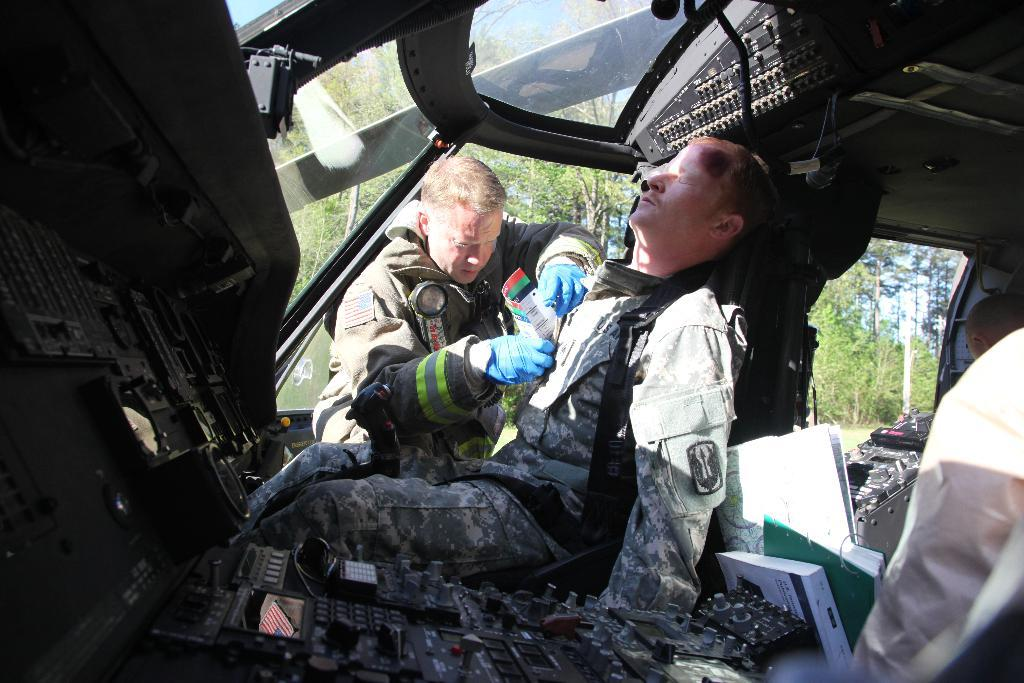What is the main subject of the image? There is a military soldier sleeping in the helicopter. Is there anyone else in the image? Yes, there is another soldier beside the sleeping soldier. What is the second soldier doing? The second soldier is putting papers in his pocket. What can be seen in the background of the image? There are many trees in the background of the image. What type of jeans is the soldier wearing in the image? There is no information about the soldier's clothing, including jeans, in the image. 